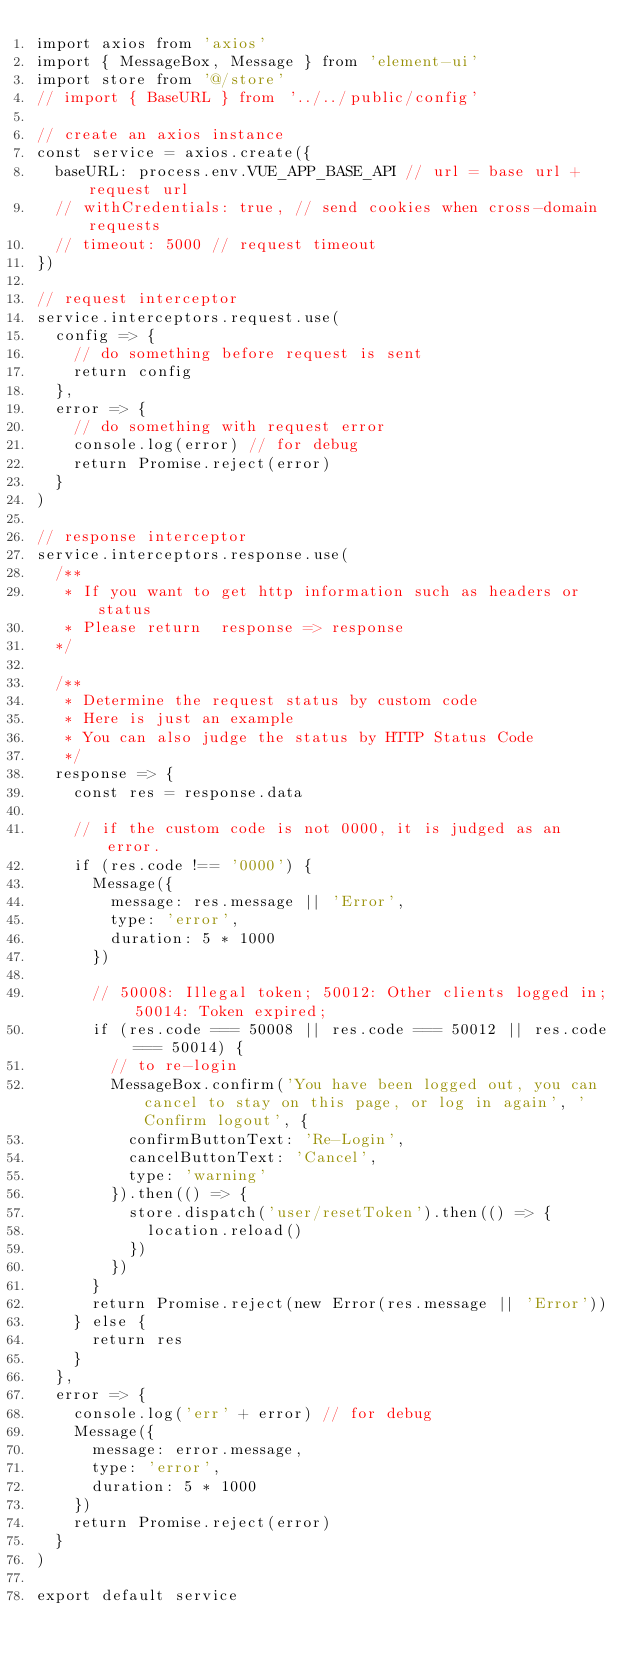Convert code to text. <code><loc_0><loc_0><loc_500><loc_500><_JavaScript_>import axios from 'axios'
import { MessageBox, Message } from 'element-ui'
import store from '@/store'
// import { BaseURL } from '../../public/config'

// create an axios instance
const service = axios.create({
  baseURL: process.env.VUE_APP_BASE_API // url = base url + request url
  // withCredentials: true, // send cookies when cross-domain requests
  // timeout: 5000 // request timeout
})

// request interceptor
service.interceptors.request.use(
  config => {
    // do something before request is sent
    return config
  },
  error => {
    // do something with request error
    console.log(error) // for debug
    return Promise.reject(error)
  }
)

// response interceptor
service.interceptors.response.use(
  /**
   * If you want to get http information such as headers or status
   * Please return  response => response
  */

  /**
   * Determine the request status by custom code
   * Here is just an example
   * You can also judge the status by HTTP Status Code
   */
  response => {
    const res = response.data

    // if the custom code is not 0000, it is judged as an error.
    if (res.code !== '0000') {
      Message({
        message: res.message || 'Error',
        type: 'error',
        duration: 5 * 1000
      })

      // 50008: Illegal token; 50012: Other clients logged in; 50014: Token expired;
      if (res.code === 50008 || res.code === 50012 || res.code === 50014) {
        // to re-login
        MessageBox.confirm('You have been logged out, you can cancel to stay on this page, or log in again', 'Confirm logout', {
          confirmButtonText: 'Re-Login',
          cancelButtonText: 'Cancel',
          type: 'warning'
        }).then(() => {
          store.dispatch('user/resetToken').then(() => {
            location.reload()
          })
        })
      }
      return Promise.reject(new Error(res.message || 'Error'))
    } else {
      return res
    }
  },
  error => {
    console.log('err' + error) // for debug
    Message({
      message: error.message,
      type: 'error',
      duration: 5 * 1000
    })
    return Promise.reject(error)
  }
)

export default service
</code> 